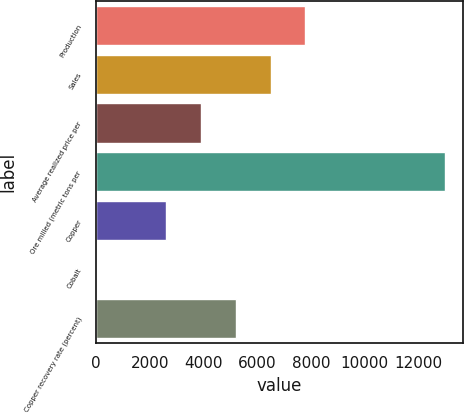<chart> <loc_0><loc_0><loc_500><loc_500><bar_chart><fcel>Production<fcel>Sales<fcel>Average realized price per<fcel>Ore milled (metric tons per<fcel>Copper<fcel>Cobalt<fcel>Copper recovery rate (percent)<nl><fcel>7800.13<fcel>6500.17<fcel>3900.25<fcel>13000<fcel>2600.29<fcel>0.37<fcel>5200.21<nl></chart> 